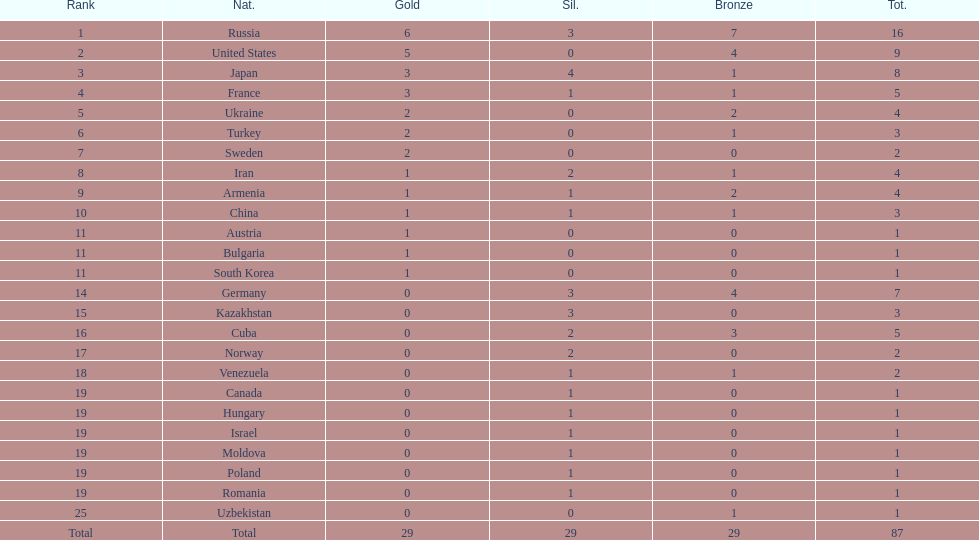Who won more gold medals than the united states? Russia. 